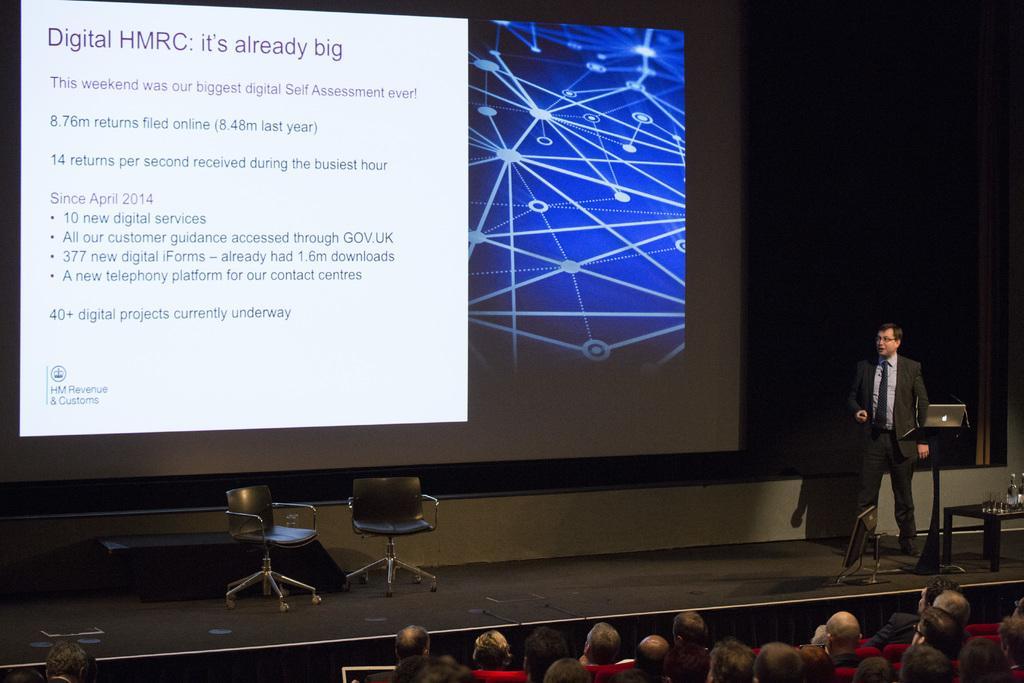Can you describe this image briefly? I can see a man standing on the stage. These are the two empty chairs. This is the screen with a display on it. There are group of people sitting on the chairs. This looks like a podium with a laptop on it. This is a table with few objects and a monitor is placed on the stage. 